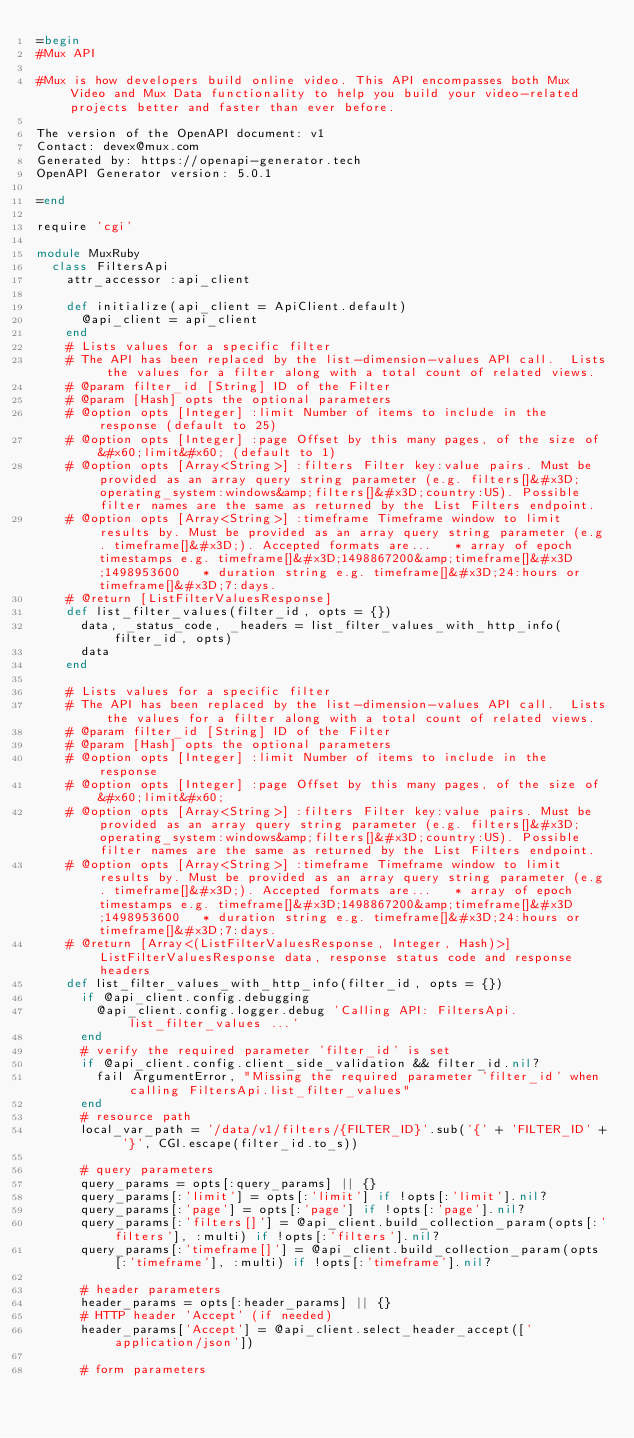<code> <loc_0><loc_0><loc_500><loc_500><_Ruby_>=begin
#Mux API

#Mux is how developers build online video. This API encompasses both Mux Video and Mux Data functionality to help you build your video-related projects better and faster than ever before.

The version of the OpenAPI document: v1
Contact: devex@mux.com
Generated by: https://openapi-generator.tech
OpenAPI Generator version: 5.0.1

=end

require 'cgi'

module MuxRuby
  class FiltersApi
    attr_accessor :api_client

    def initialize(api_client = ApiClient.default)
      @api_client = api_client
    end
    # Lists values for a specific filter
    # The API has been replaced by the list-dimension-values API call.  Lists the values for a filter along with a total count of related views. 
    # @param filter_id [String] ID of the Filter
    # @param [Hash] opts the optional parameters
    # @option opts [Integer] :limit Number of items to include in the response (default to 25)
    # @option opts [Integer] :page Offset by this many pages, of the size of &#x60;limit&#x60; (default to 1)
    # @option opts [Array<String>] :filters Filter key:value pairs. Must be provided as an array query string parameter (e.g. filters[]&#x3D;operating_system:windows&amp;filters[]&#x3D;country:US). Possible filter names are the same as returned by the List Filters endpoint. 
    # @option opts [Array<String>] :timeframe Timeframe window to limit results by. Must be provided as an array query string parameter (e.g. timeframe[]&#x3D;). Accepted formats are...   * array of epoch timestamps e.g. timeframe[]&#x3D;1498867200&amp;timeframe[]&#x3D;1498953600   * duration string e.g. timeframe[]&#x3D;24:hours or timeframe[]&#x3D;7:days. 
    # @return [ListFilterValuesResponse]
    def list_filter_values(filter_id, opts = {})
      data, _status_code, _headers = list_filter_values_with_http_info(filter_id, opts)
      data
    end

    # Lists values for a specific filter
    # The API has been replaced by the list-dimension-values API call.  Lists the values for a filter along with a total count of related views. 
    # @param filter_id [String] ID of the Filter
    # @param [Hash] opts the optional parameters
    # @option opts [Integer] :limit Number of items to include in the response
    # @option opts [Integer] :page Offset by this many pages, of the size of &#x60;limit&#x60;
    # @option opts [Array<String>] :filters Filter key:value pairs. Must be provided as an array query string parameter (e.g. filters[]&#x3D;operating_system:windows&amp;filters[]&#x3D;country:US). Possible filter names are the same as returned by the List Filters endpoint. 
    # @option opts [Array<String>] :timeframe Timeframe window to limit results by. Must be provided as an array query string parameter (e.g. timeframe[]&#x3D;). Accepted formats are...   * array of epoch timestamps e.g. timeframe[]&#x3D;1498867200&amp;timeframe[]&#x3D;1498953600   * duration string e.g. timeframe[]&#x3D;24:hours or timeframe[]&#x3D;7:days. 
    # @return [Array<(ListFilterValuesResponse, Integer, Hash)>] ListFilterValuesResponse data, response status code and response headers
    def list_filter_values_with_http_info(filter_id, opts = {})
      if @api_client.config.debugging
        @api_client.config.logger.debug 'Calling API: FiltersApi.list_filter_values ...'
      end
      # verify the required parameter 'filter_id' is set
      if @api_client.config.client_side_validation && filter_id.nil?
        fail ArgumentError, "Missing the required parameter 'filter_id' when calling FiltersApi.list_filter_values"
      end
      # resource path
      local_var_path = '/data/v1/filters/{FILTER_ID}'.sub('{' + 'FILTER_ID' + '}', CGI.escape(filter_id.to_s))

      # query parameters
      query_params = opts[:query_params] || {}
      query_params[:'limit'] = opts[:'limit'] if !opts[:'limit'].nil?
      query_params[:'page'] = opts[:'page'] if !opts[:'page'].nil?
      query_params[:'filters[]'] = @api_client.build_collection_param(opts[:'filters'], :multi) if !opts[:'filters'].nil?
      query_params[:'timeframe[]'] = @api_client.build_collection_param(opts[:'timeframe'], :multi) if !opts[:'timeframe'].nil?

      # header parameters
      header_params = opts[:header_params] || {}
      # HTTP header 'Accept' (if needed)
      header_params['Accept'] = @api_client.select_header_accept(['application/json'])

      # form parameters</code> 